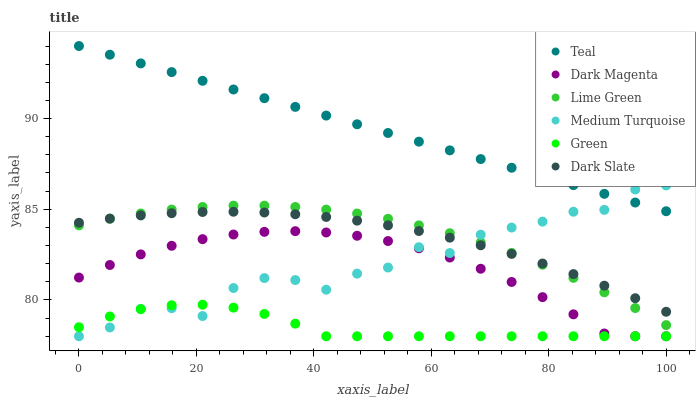Does Green have the minimum area under the curve?
Answer yes or no. Yes. Does Teal have the maximum area under the curve?
Answer yes or no. Yes. Does Dark Magenta have the minimum area under the curve?
Answer yes or no. No. Does Dark Magenta have the maximum area under the curve?
Answer yes or no. No. Is Teal the smoothest?
Answer yes or no. Yes. Is Medium Turquoise the roughest?
Answer yes or no. Yes. Is Dark Magenta the smoothest?
Answer yes or no. No. Is Dark Magenta the roughest?
Answer yes or no. No. Does Dark Magenta have the lowest value?
Answer yes or no. Yes. Does Dark Slate have the lowest value?
Answer yes or no. No. Does Teal have the highest value?
Answer yes or no. Yes. Does Dark Magenta have the highest value?
Answer yes or no. No. Is Dark Slate less than Teal?
Answer yes or no. Yes. Is Teal greater than Green?
Answer yes or no. Yes. Does Green intersect Medium Turquoise?
Answer yes or no. Yes. Is Green less than Medium Turquoise?
Answer yes or no. No. Is Green greater than Medium Turquoise?
Answer yes or no. No. Does Dark Slate intersect Teal?
Answer yes or no. No. 